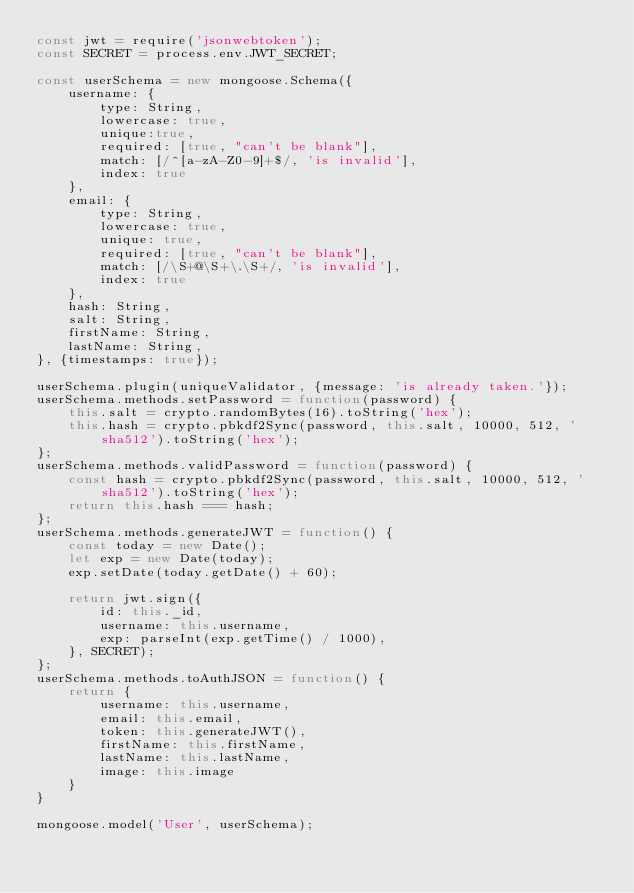<code> <loc_0><loc_0><loc_500><loc_500><_JavaScript_>const jwt = require('jsonwebtoken');
const SECRET = process.env.JWT_SECRET;

const userSchema = new mongoose.Schema({
    username: {
        type: String,
        lowercase: true,
        unique:true,
        required: [true, "can't be blank"],
        match: [/^[a-zA-Z0-9]+$/, 'is invalid'],
        index: true
    },
    email: {
        type: String,
        lowercase: true,
        unique: true,
        required: [true, "can't be blank"],
        match: [/\S+@\S+\.\S+/, 'is invalid'],
        index: true
    },
    hash: String,
    salt: String,
    firstName: String,
    lastName: String,
}, {timestamps: true});

userSchema.plugin(uniqueValidator, {message: 'is already taken.'});
userSchema.methods.setPassword = function(password) {
    this.salt = crypto.randomBytes(16).toString('hex');
    this.hash = crypto.pbkdf2Sync(password, this.salt, 10000, 512, 'sha512').toString('hex');
};
userSchema.methods.validPassword = function(password) {
    const hash = crypto.pbkdf2Sync(password, this.salt, 10000, 512, 'sha512').toString('hex');
    return this.hash === hash;
};
userSchema.methods.generateJWT = function() {
    const today = new Date();
    let exp = new Date(today);
    exp.setDate(today.getDate() + 60);

    return jwt.sign({
        id: this._id,
        username: this.username,
        exp: parseInt(exp.getTime() / 1000),
    }, SECRET);
};
userSchema.methods.toAuthJSON = function() {
    return {
        username: this.username,
        email: this.email,
        token: this.generateJWT(),
        firstName: this.firstName,
        lastName: this.lastName,
        image: this.image
    }
}

mongoose.model('User', userSchema);</code> 